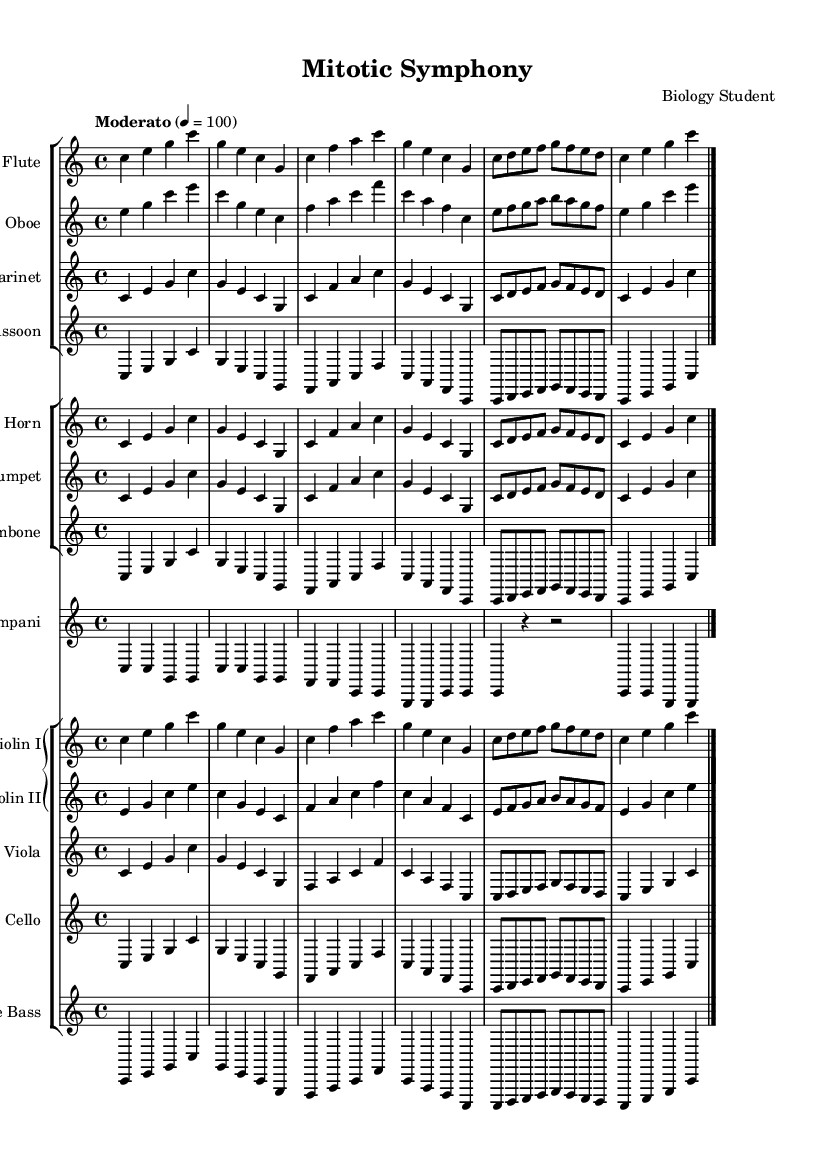What is the key signature of this music? The key signature indicated in the score is C major, which has no sharps or flats. This can be visually confirmed by looking at the notation at the beginning of the staff.
Answer: C major What is the time signature of this music? The time signature shown at the beginning of the score is 4/4, meaning there are four beats in each measure and the quarter note receives one beat. This information is clearly displayed in the top left of the score.
Answer: 4/4 What is the tempo marking of this piece? The tempo marking at the beginning states "Moderato" with a metronome marking of 4 = 100, which means the piece is to be played at a moderate pace at 100 beats per minute. This is specified right under the global section.
Answer: Moderato How many different instrument groups are there in this symphony? The score consists of three groups: Woodwinds, Brass, and Strings. Each group includes several instruments collaborative in this orchestral setting. This can be counted by observing the staff groups within the score layout.
Answer: Three Which instruments are featured in the Woodwind group? The Woodwind group includes Flute, Oboe, Clarinet, and Bassoon. We can determine this by looking at the staff section that is categorized for Woodwinds in the score layout.
Answer: Flute, Oboe, Clarinet, Bassoon What is the lowest instrument in this orchestral piece? The lowest instrument in this symphony is the Double Bass, as it typically has the lowest range and is positioned lower on the Grand Staff within the score. This can be identified by reviewing the instrument names and their corresponding staves.
Answer: Double Bass What musical concept does this symphonic piece represent? This symphony represents the biological process of mitosis and cell division, which is directly indicated in the title "Mitotic Symphony." It creatively depicts the phases of cellular division through orchestral movements, as suggested by its thematic concept.
Answer: Mitosis 